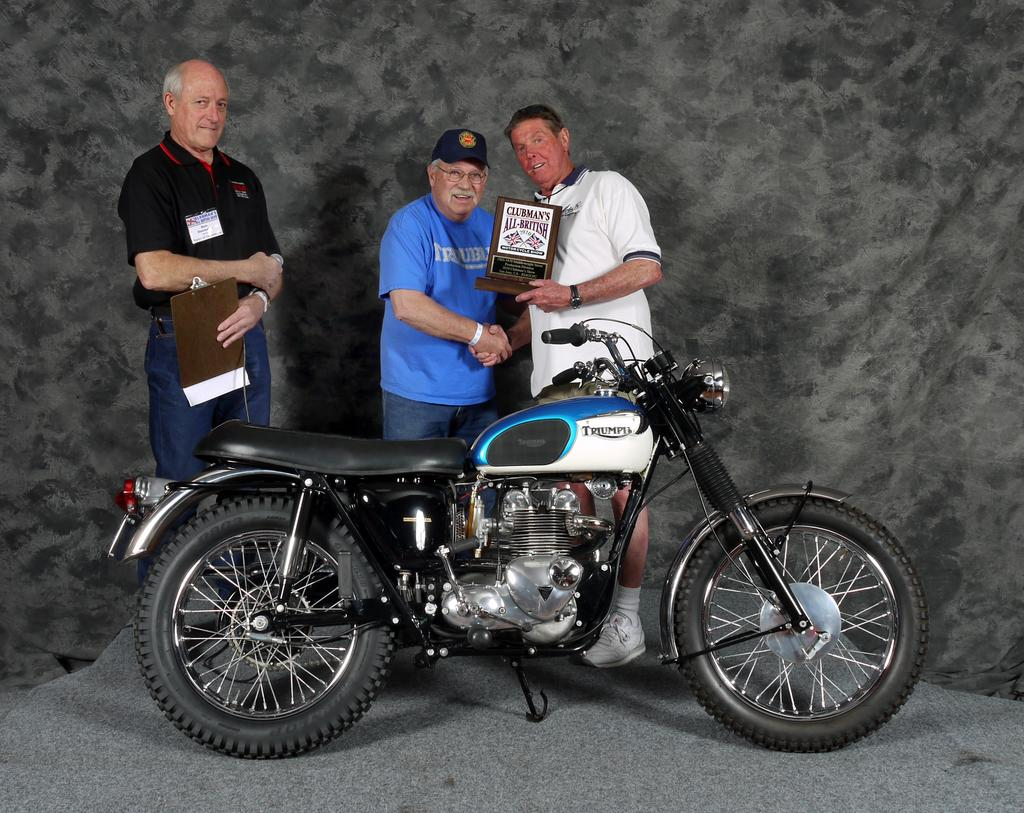How many people are in the image? There are three people in the image. What are the three people doing in the image? The three people are holding an object. What can be seen behind the three people? The three people are standing behind a bike. Can you see any bombs in the image? No, there are no bombs present in the image. What type of ear is visible on one of the people in the image? There is no ear visible on any of the people in the image. 